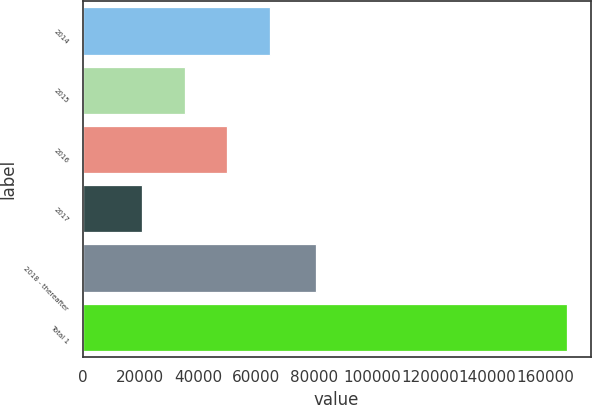<chart> <loc_0><loc_0><loc_500><loc_500><bar_chart><fcel>2014<fcel>2015<fcel>2016<fcel>2017<fcel>2018 - thereafter<fcel>Total 1<nl><fcel>64689.9<fcel>35371.3<fcel>50030.6<fcel>20712<fcel>80784<fcel>167305<nl></chart> 